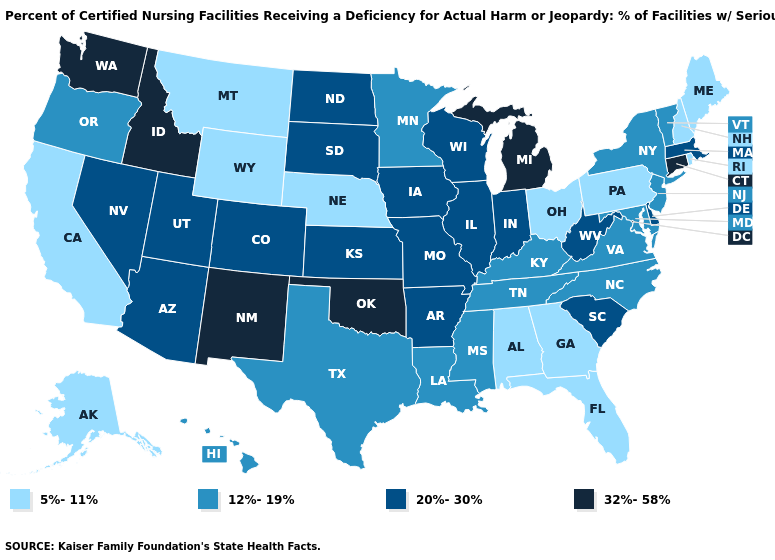What is the value of Iowa?
Write a very short answer. 20%-30%. Does Utah have a higher value than Michigan?
Short answer required. No. Does Florida have a higher value than North Carolina?
Quick response, please. No. Name the states that have a value in the range 5%-11%?
Keep it brief. Alabama, Alaska, California, Florida, Georgia, Maine, Montana, Nebraska, New Hampshire, Ohio, Pennsylvania, Rhode Island, Wyoming. Among the states that border Rhode Island , which have the lowest value?
Give a very brief answer. Massachusetts. What is the highest value in states that border Minnesota?
Quick response, please. 20%-30%. What is the value of Texas?
Be succinct. 12%-19%. Among the states that border New Hampshire , which have the highest value?
Answer briefly. Massachusetts. What is the value of New Jersey?
Answer briefly. 12%-19%. What is the highest value in the MidWest ?
Give a very brief answer. 32%-58%. What is the value of Arizona?
Keep it brief. 20%-30%. Which states have the lowest value in the West?
Keep it brief. Alaska, California, Montana, Wyoming. Is the legend a continuous bar?
Write a very short answer. No. What is the value of Massachusetts?
Keep it brief. 20%-30%. Does New Mexico have the highest value in the USA?
Be succinct. Yes. 